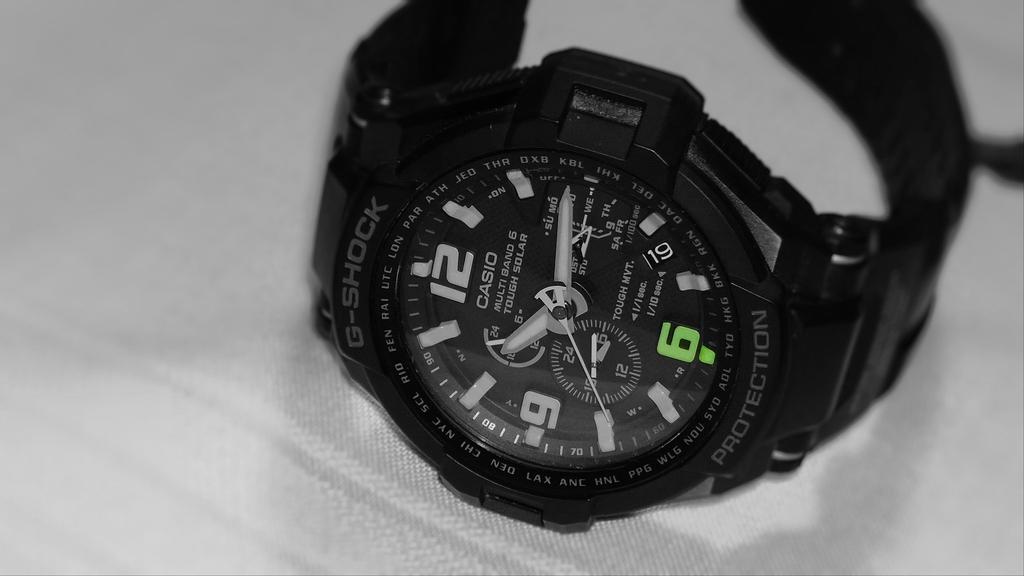What color is the six number?
Your answer should be compact. Green. 